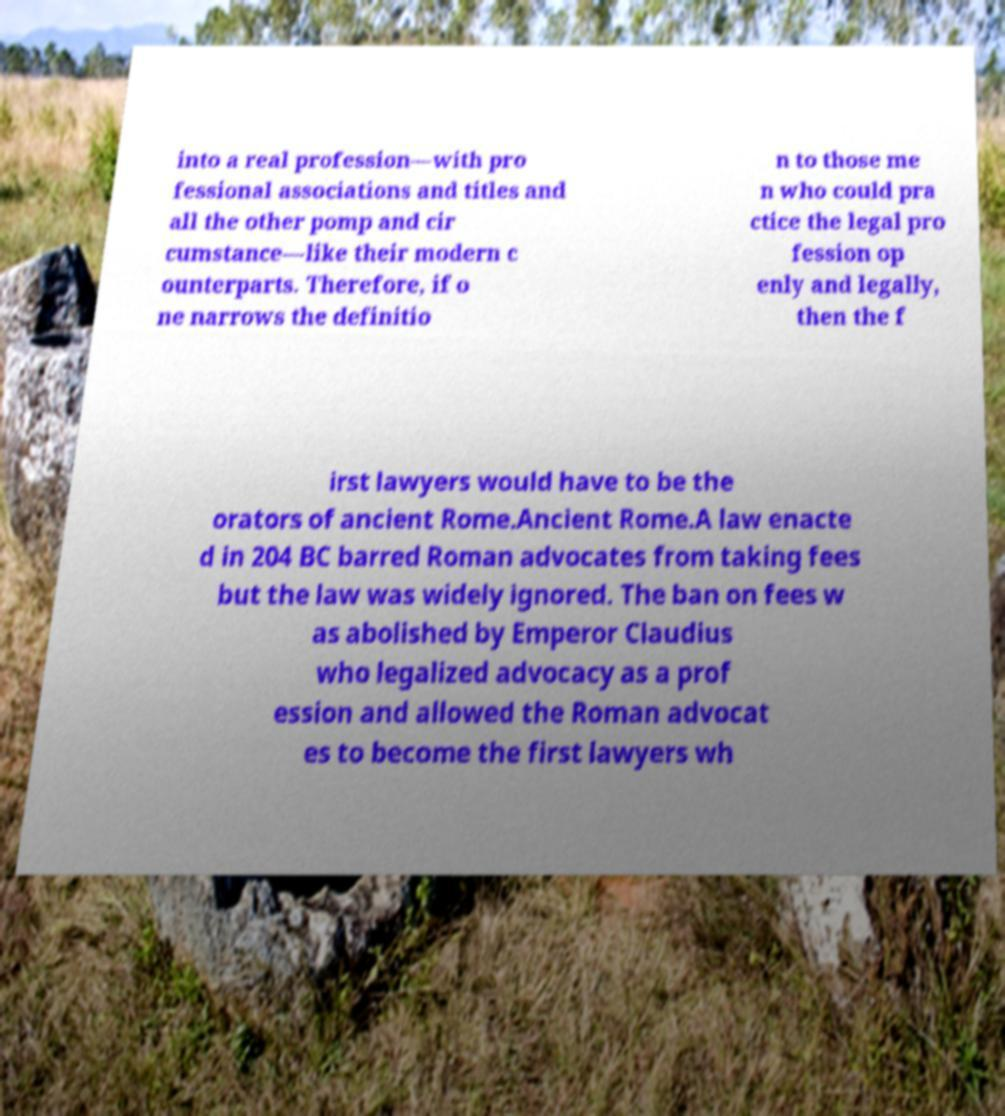For documentation purposes, I need the text within this image transcribed. Could you provide that? into a real profession—with pro fessional associations and titles and all the other pomp and cir cumstance—like their modern c ounterparts. Therefore, if o ne narrows the definitio n to those me n who could pra ctice the legal pro fession op enly and legally, then the f irst lawyers would have to be the orators of ancient Rome.Ancient Rome.A law enacte d in 204 BC barred Roman advocates from taking fees but the law was widely ignored. The ban on fees w as abolished by Emperor Claudius who legalized advocacy as a prof ession and allowed the Roman advocat es to become the first lawyers wh 